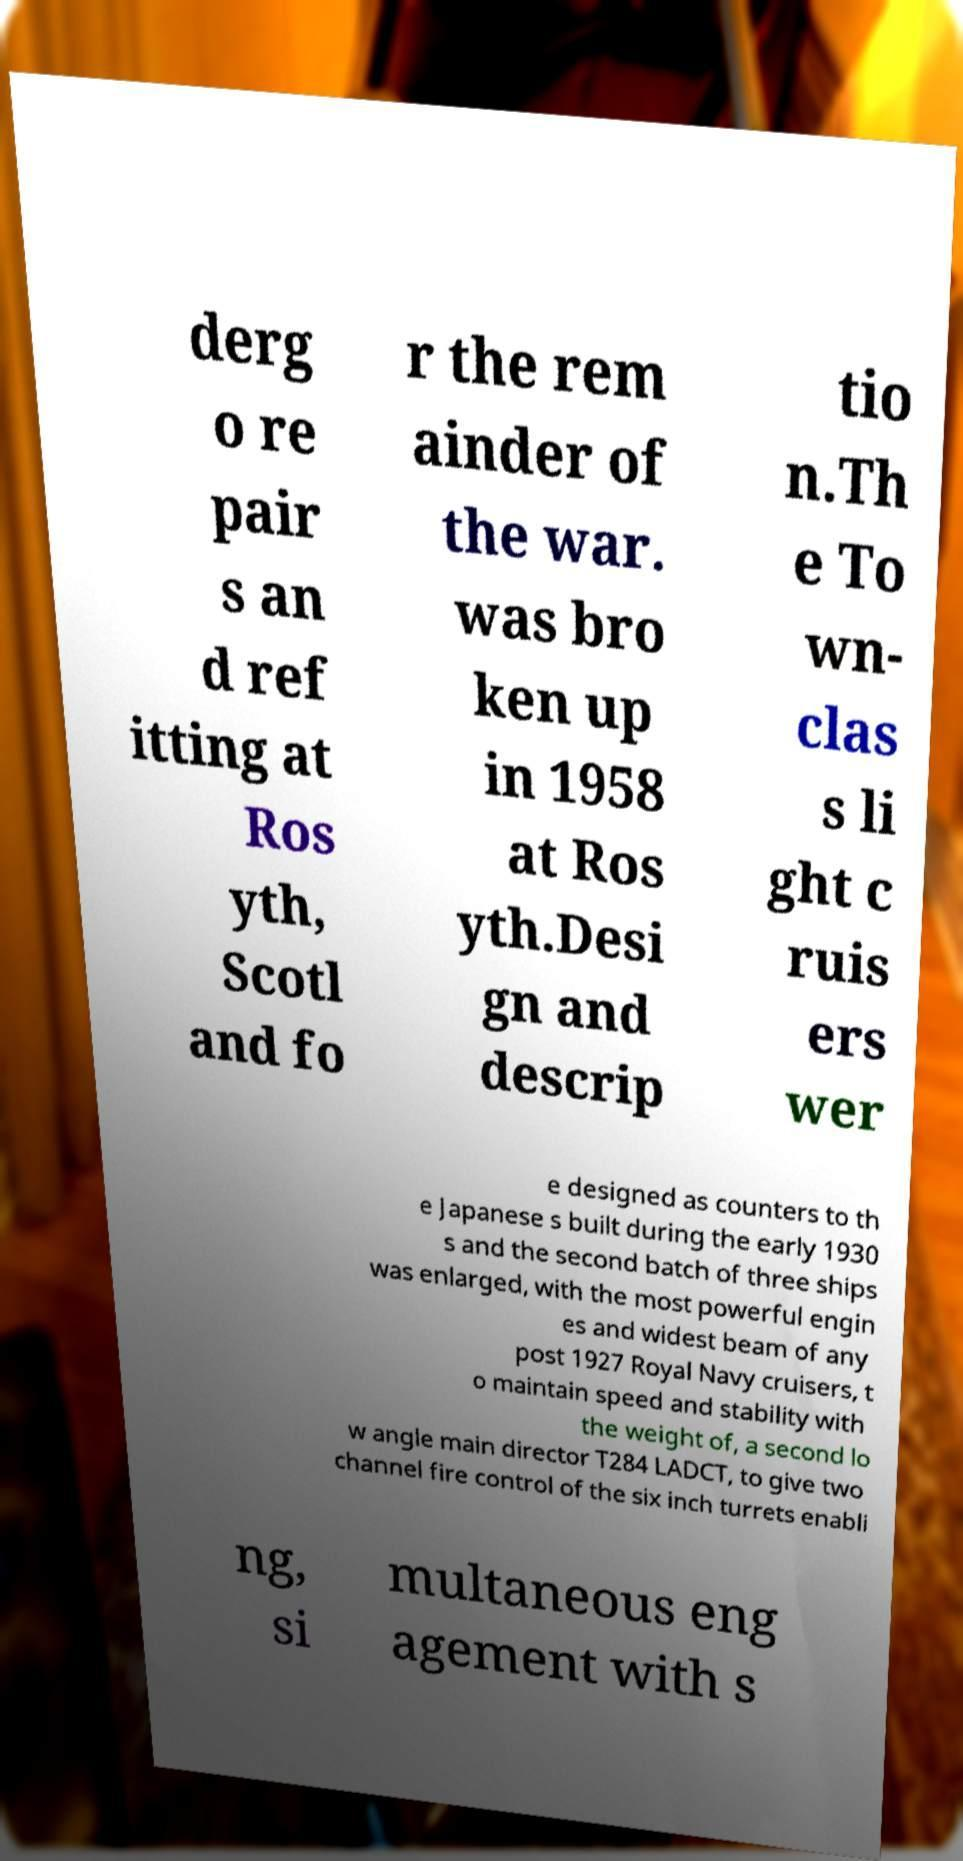Could you extract and type out the text from this image? derg o re pair s an d ref itting at Ros yth, Scotl and fo r the rem ainder of the war. was bro ken up in 1958 at Ros yth.Desi gn and descrip tio n.Th e To wn- clas s li ght c ruis ers wer e designed as counters to th e Japanese s built during the early 1930 s and the second batch of three ships was enlarged, with the most powerful engin es and widest beam of any post 1927 Royal Navy cruisers, t o maintain speed and stability with the weight of, a second lo w angle main director T284 LADCT, to give two channel fire control of the six inch turrets enabli ng, si multaneous eng agement with s 